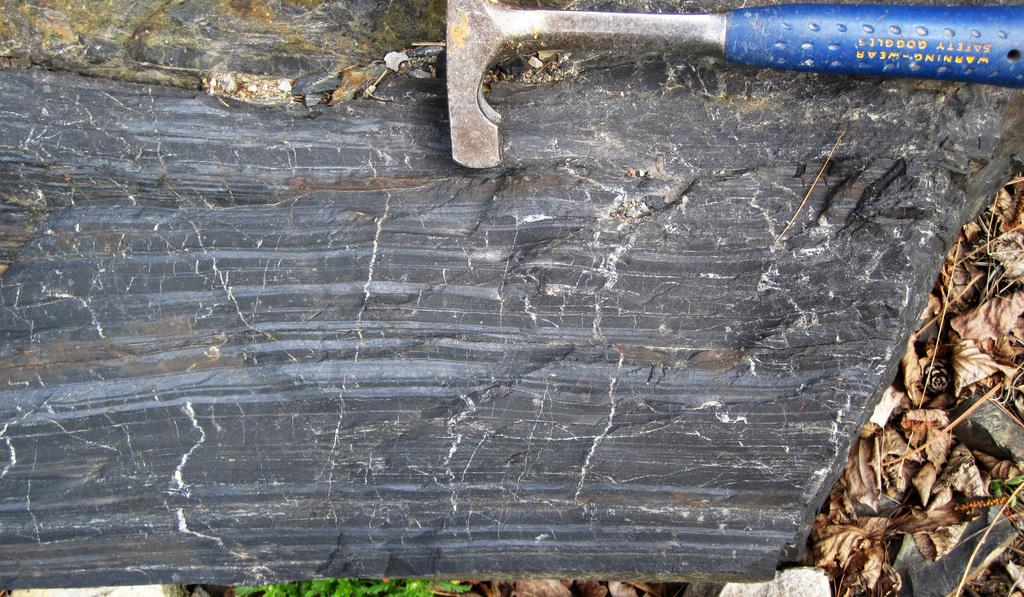What object is in the image that can be used for striking or breaking? There is a hammer in the image. What is the hammer resting on in the image? The hammer is on a rock. What type of vegetation can be seen on the right side of the image? There are dried leaves on the right side of the image. How many people are in the crowd depicted in the image? There is no crowd present in the image; it features a hammer on a rock and dried leaves. What type of bone can be seen in the image? There is no bone present in the image. 